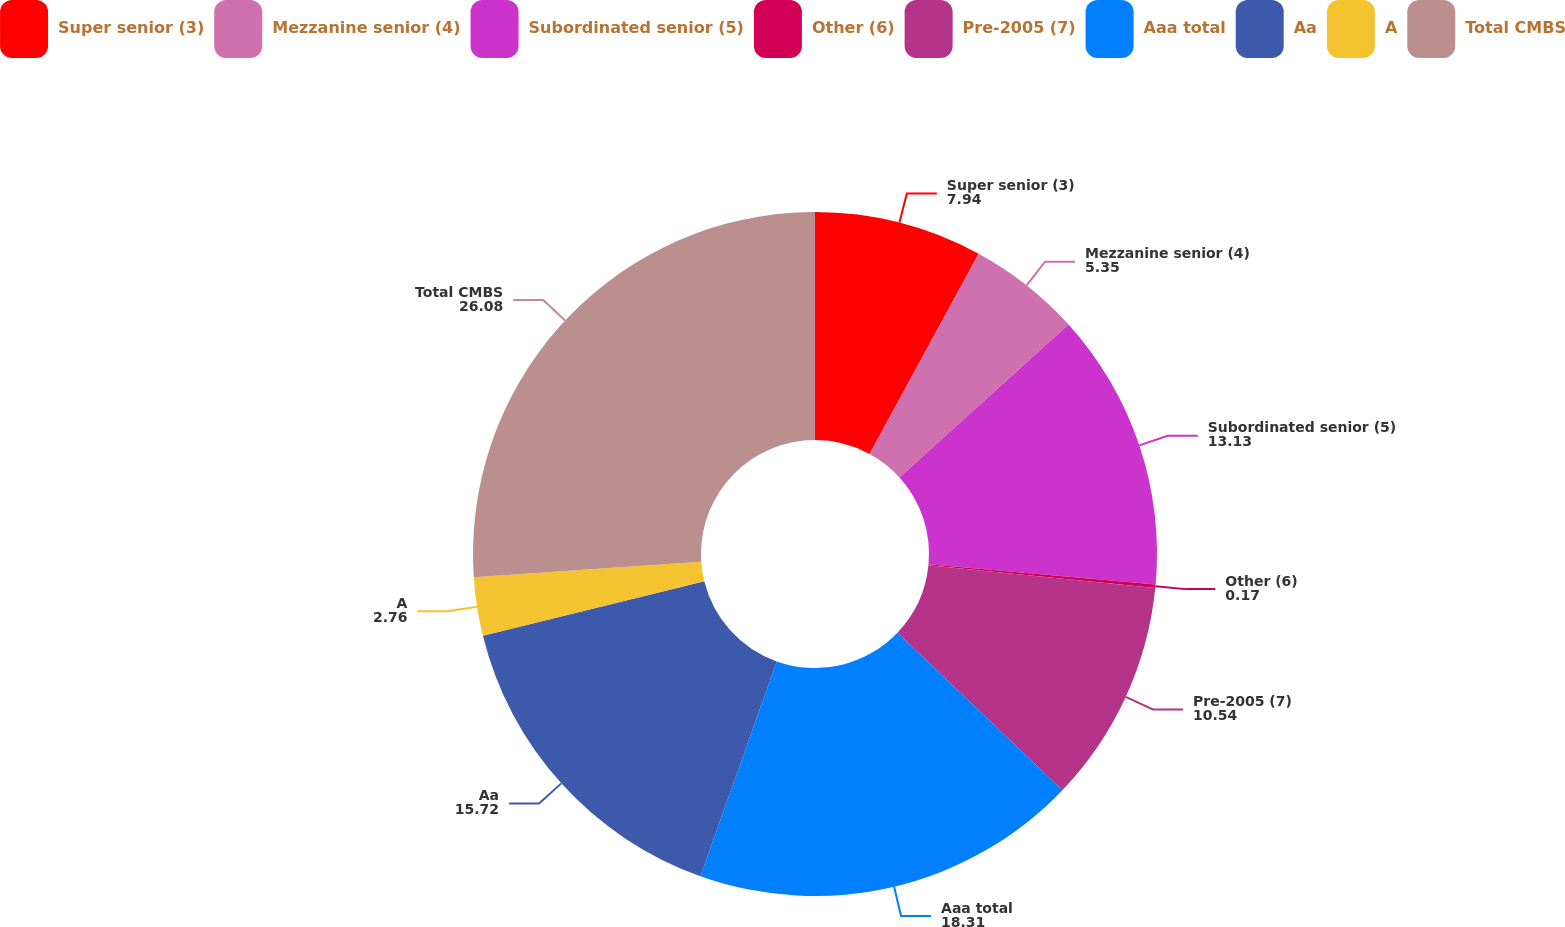<chart> <loc_0><loc_0><loc_500><loc_500><pie_chart><fcel>Super senior (3)<fcel>Mezzanine senior (4)<fcel>Subordinated senior (5)<fcel>Other (6)<fcel>Pre-2005 (7)<fcel>Aaa total<fcel>Aa<fcel>A<fcel>Total CMBS<nl><fcel>7.94%<fcel>5.35%<fcel>13.13%<fcel>0.17%<fcel>10.54%<fcel>18.31%<fcel>15.72%<fcel>2.76%<fcel>26.08%<nl></chart> 